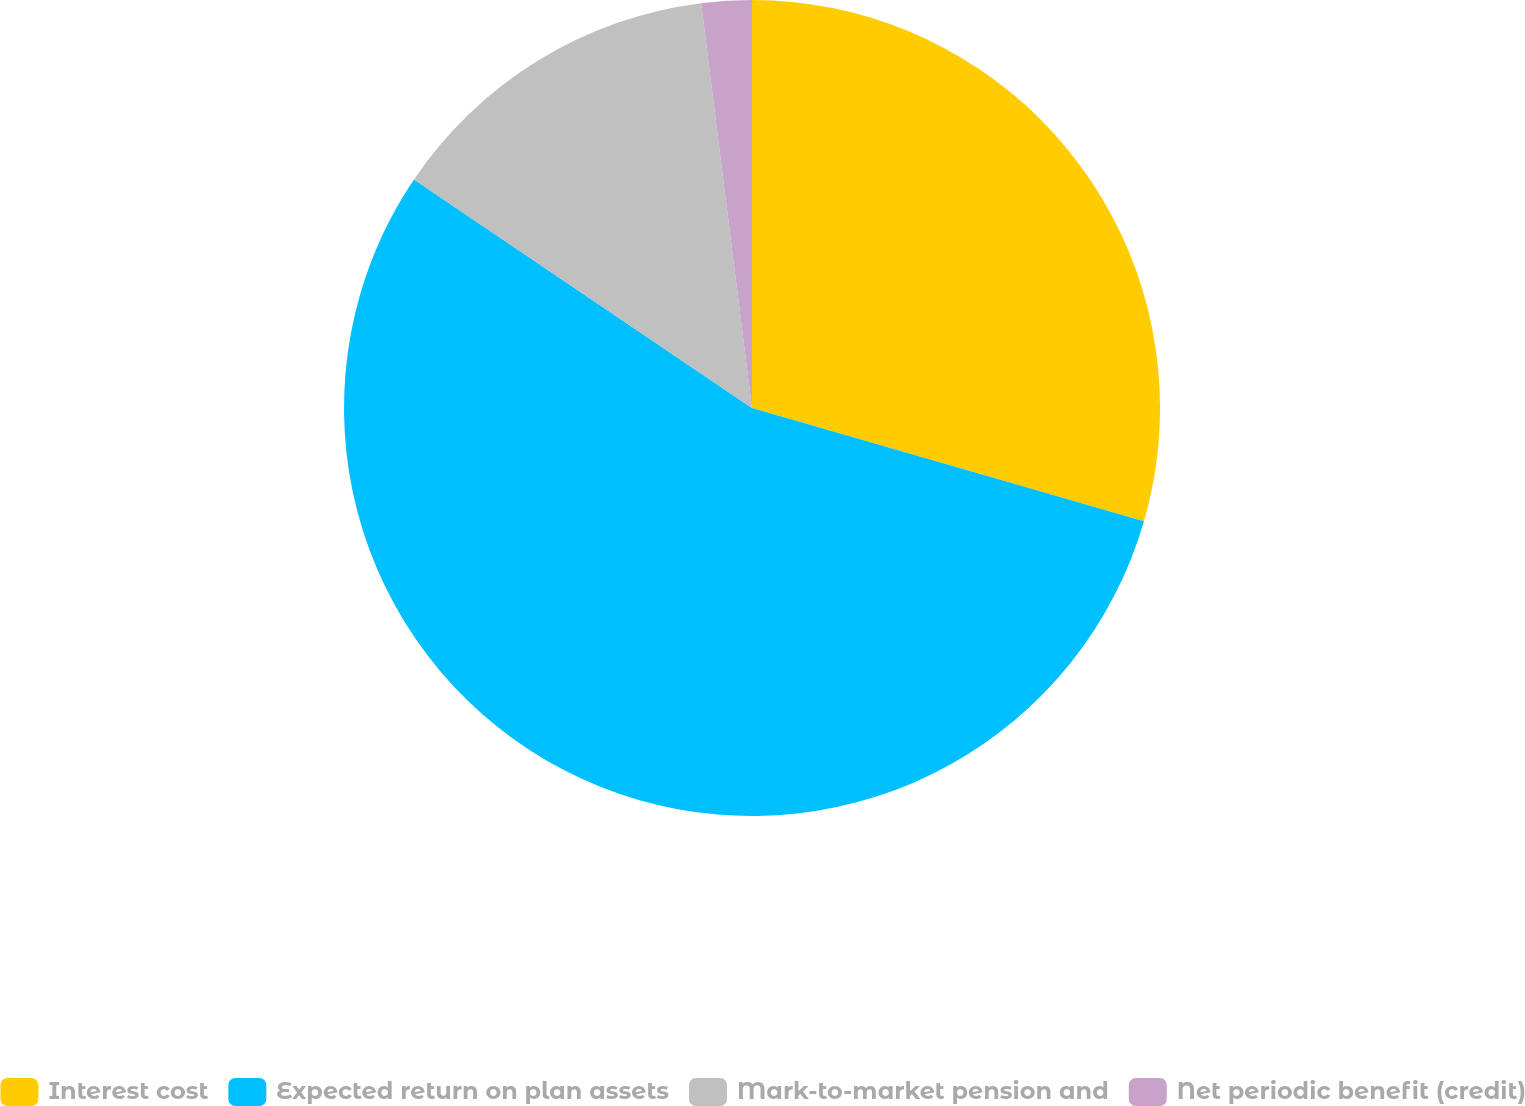Convert chart to OTSL. <chart><loc_0><loc_0><loc_500><loc_500><pie_chart><fcel>Interest cost<fcel>Expected return on plan assets<fcel>Mark-to-market pension and<fcel>Net periodic benefit (credit)<nl><fcel>29.48%<fcel>54.98%<fcel>13.55%<fcel>1.99%<nl></chart> 